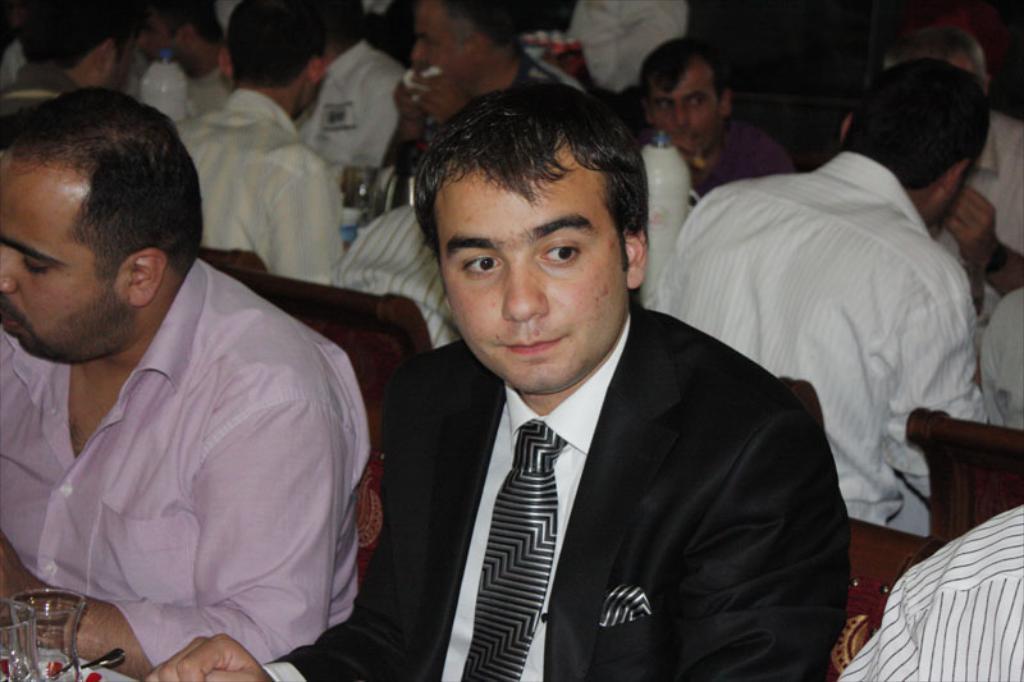Please provide a concise description of this image. In the image I can see some people are sitting in front of the table on which there are some things placed, among them a person is wearing the suit. 